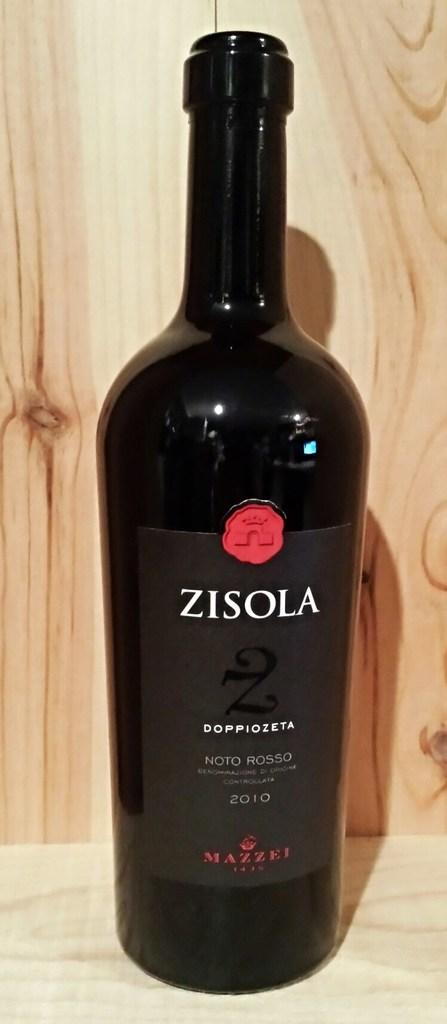<image>
Present a compact description of the photo's key features. A bottle of Zisola Noto Rossa wine sits on a wooden shelf 